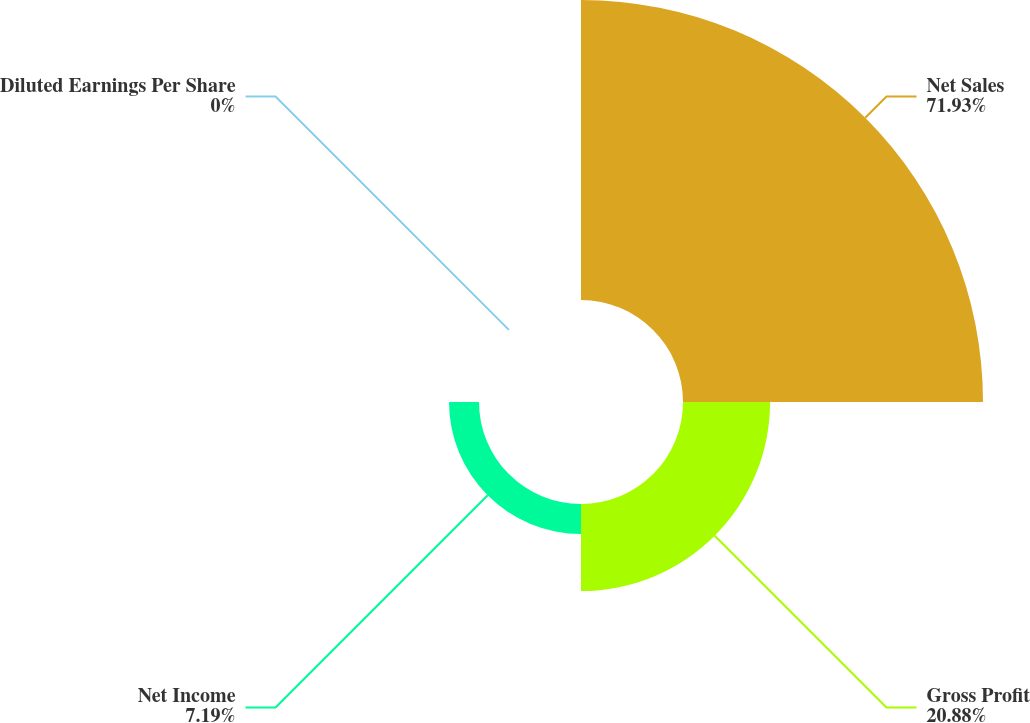<chart> <loc_0><loc_0><loc_500><loc_500><pie_chart><fcel>Net Sales<fcel>Gross Profit<fcel>Net Income<fcel>Diluted Earnings Per Share<nl><fcel>71.93%<fcel>20.88%<fcel>7.19%<fcel>0.0%<nl></chart> 